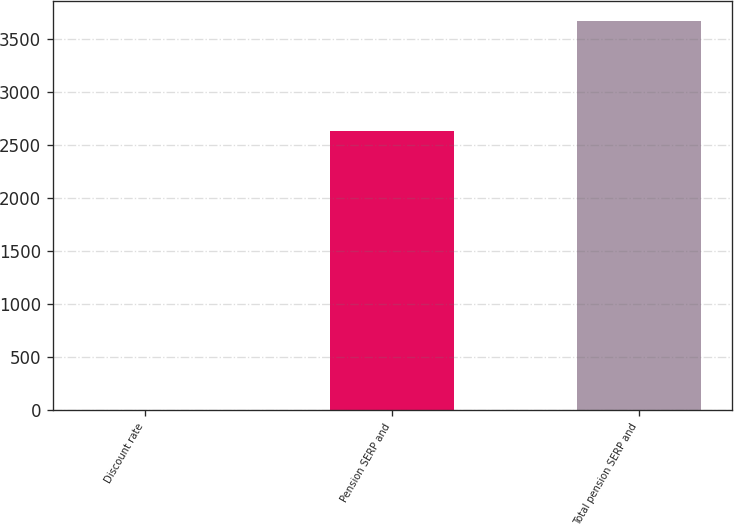Convert chart to OTSL. <chart><loc_0><loc_0><loc_500><loc_500><bar_chart><fcel>Discount rate<fcel>Pension SERP and<fcel>Total pension SERP and<nl><fcel>3.5<fcel>2627<fcel>3668<nl></chart> 